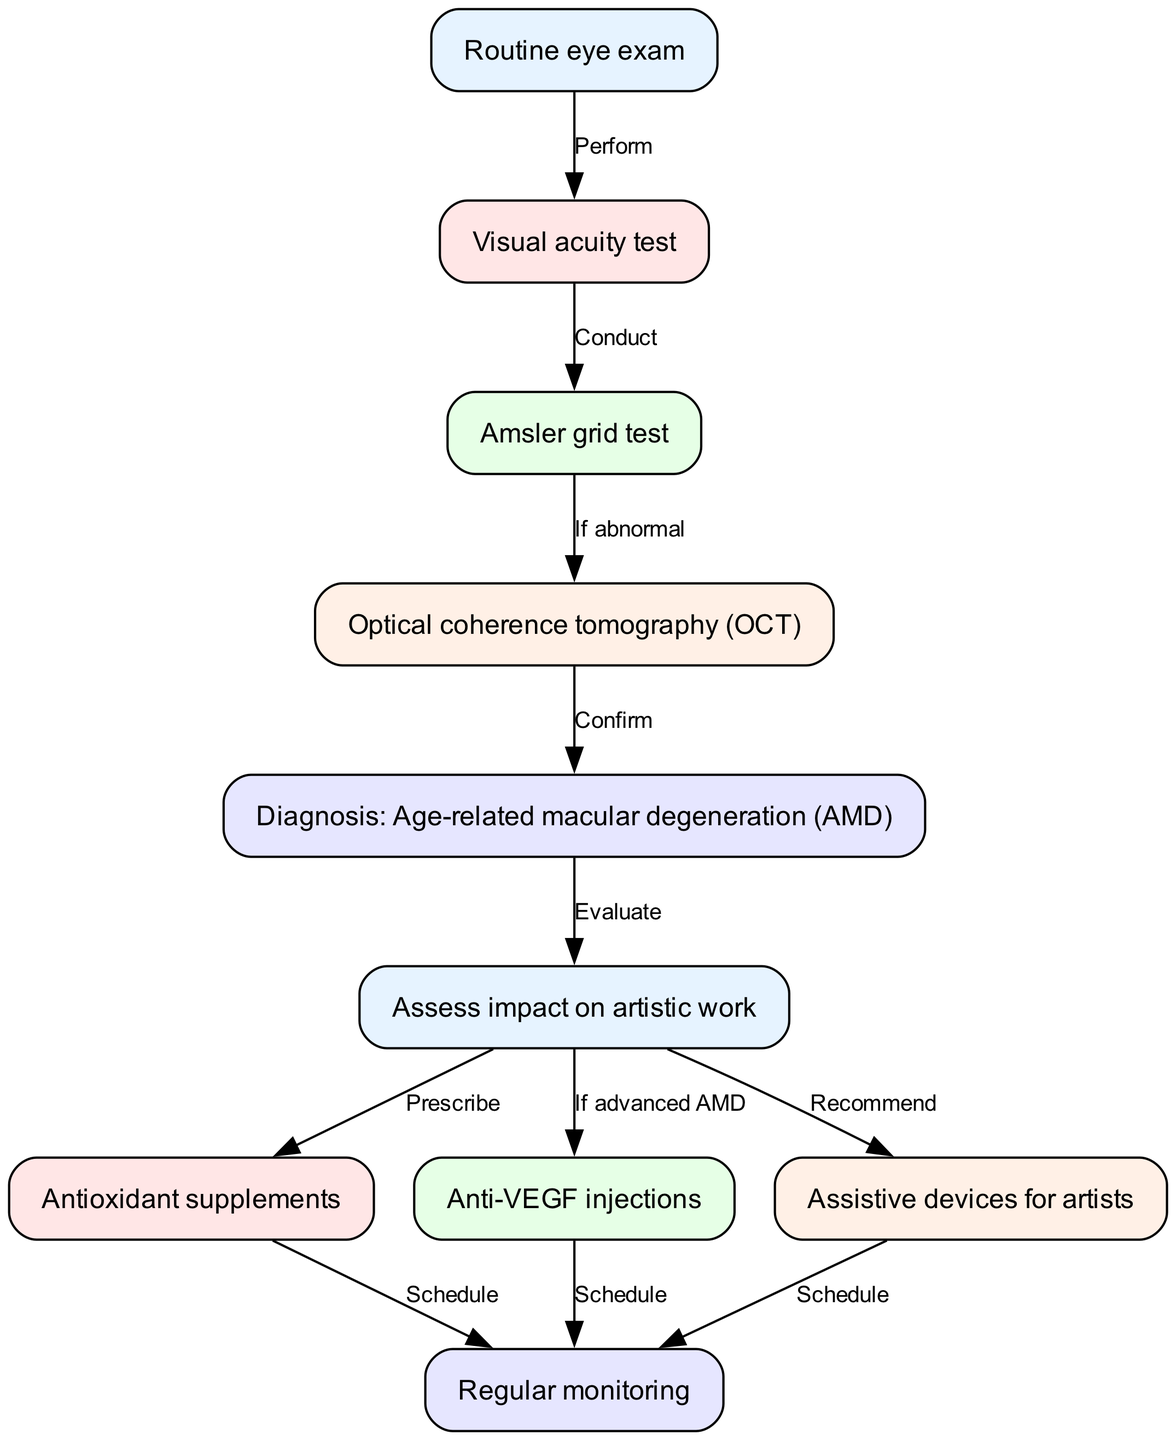What is the first step in the clinical pathway? The diagram indicates that the first step in the clinical pathway is "Routine eye exam." This is the starting point as it initiates the diagnostic process.
Answer: Routine eye exam How many tests are conducted before diagnosis? The diagram shows three tests (Visual acuity test, Amsler grid test, Optical coherence tomography) are conducted before reaching the diagnosis of age-related macular degeneration.
Answer: 3 What happens if the Amsler grid test is abnormal? If the Amsler grid test is abnormal, the next step is to conduct the Optical coherence tomography (OCT) to further analyze the situation.
Answer: Conduct Optical coherence tomography (OCT) What is assessed after the diagnosis of AMD? After diagnosing AMD, the clinical pathway indicates that there is an evaluation of how AMD will impact the artistic work of the individual.
Answer: Assess impact on artistic work What are the treatments recommended after evaluating the impact on artistic work? Following the evaluation, the diagram shows three recommended treatments: Antioxidant supplements, Anti-VEGF injections (if advanced AMD), and Assistive devices for artists.
Answer: Antioxidant supplements, Anti-VEGF injections, Assistive devices for artists What is scheduled after prescribing antioxidant supplements? The pathway indicates that after prescribing antioxidant supplements, the next step is to schedule regular monitoring of the patient's condition.
Answer: Schedule regular monitoring Which node connects to the diagnosis of age-related macular degeneration? The node that connects to the diagnosis of age-related macular degeneration is the Optical coherence tomography (OCT), which confirms the diagnosis.
Answer: Optical coherence tomography (OCT) What could happen if age-related macular degeneration is advanced? The diagram specifies that if age-related macular degeneration is advanced, Anti-VEGF injections are recommended as a treatment option.
Answer: Anti-VEGF injections How many treatment options are there in total after assessing artistic work? The diagram indicates there are three treatment options available after assessing the impact on artistic work.
Answer: 3 